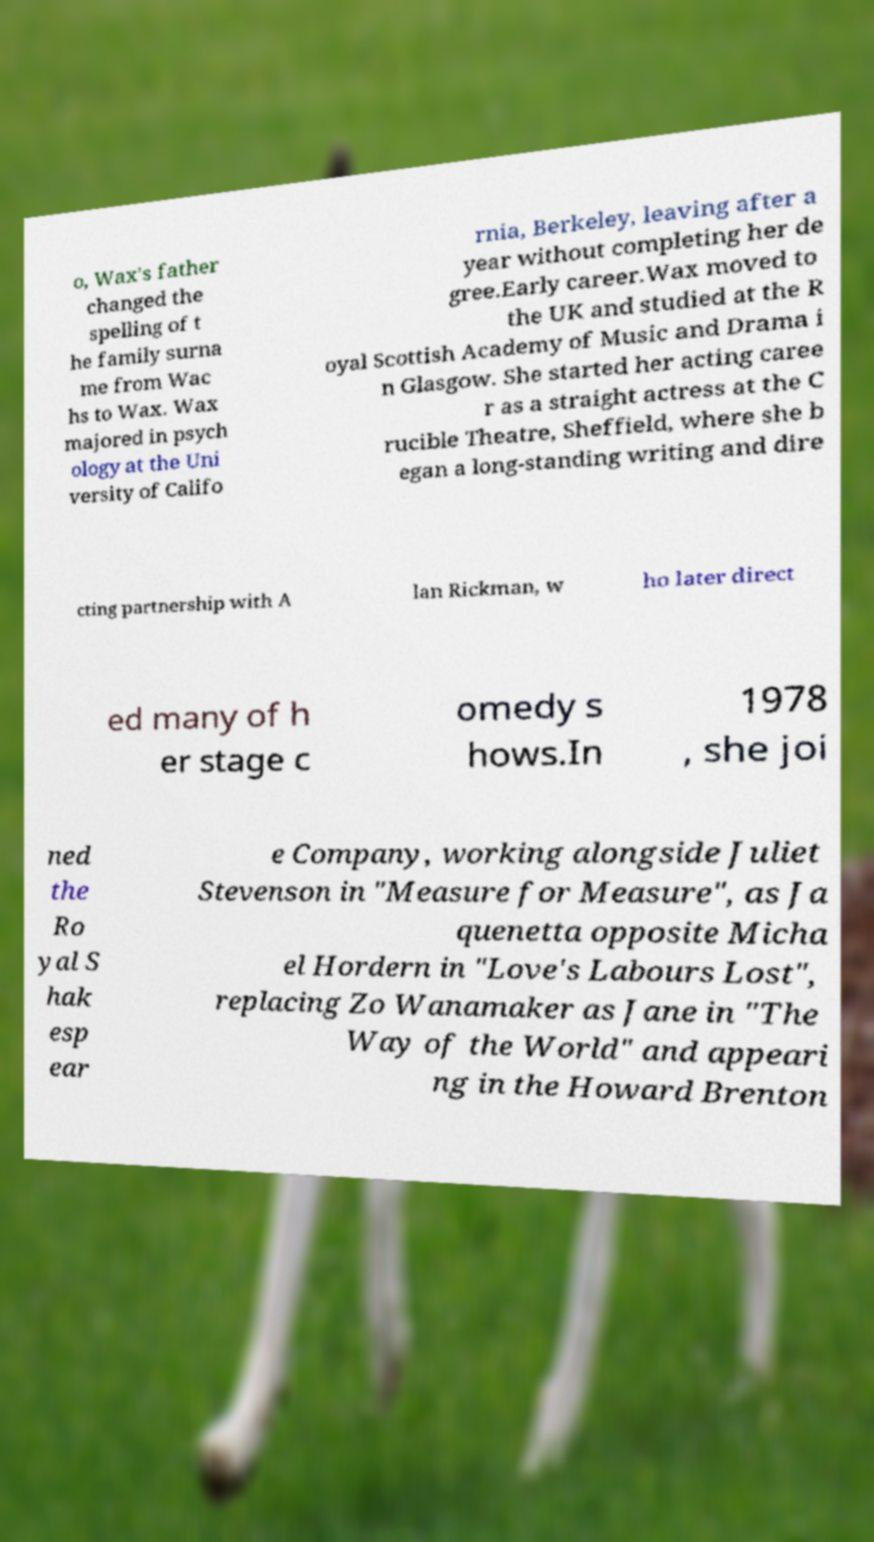Please identify and transcribe the text found in this image. o, Wax's father changed the spelling of t he family surna me from Wac hs to Wax. Wax majored in psych ology at the Uni versity of Califo rnia, Berkeley, leaving after a year without completing her de gree.Early career.Wax moved to the UK and studied at the R oyal Scottish Academy of Music and Drama i n Glasgow. She started her acting caree r as a straight actress at the C rucible Theatre, Sheffield, where she b egan a long-standing writing and dire cting partnership with A lan Rickman, w ho later direct ed many of h er stage c omedy s hows.In 1978 , she joi ned the Ro yal S hak esp ear e Company, working alongside Juliet Stevenson in "Measure for Measure", as Ja quenetta opposite Micha el Hordern in "Love's Labours Lost", replacing Zo Wanamaker as Jane in "The Way of the World" and appeari ng in the Howard Brenton 